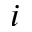<formula> <loc_0><loc_0><loc_500><loc_500>i</formula> 